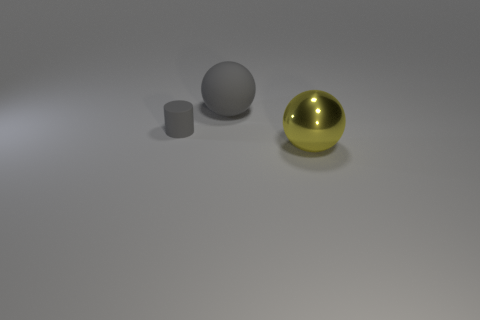How many other things are there of the same color as the shiny sphere?
Keep it short and to the point. 0. Is the material of the ball behind the yellow metal sphere the same as the object that is in front of the cylinder?
Your answer should be compact. No. There is a ball that is on the left side of the big yellow ball; what is its size?
Give a very brief answer. Large. There is a large gray thing that is the same shape as the large yellow thing; what is it made of?
Offer a terse response. Rubber. Is there anything else that is the same size as the gray cylinder?
Provide a succinct answer. No. The big object that is behind the big yellow metallic ball has what shape?
Ensure brevity in your answer.  Sphere. What number of small rubber objects have the same shape as the big gray object?
Your answer should be very brief. 0. Are there an equal number of tiny cylinders that are behind the small gray cylinder and big rubber objects that are to the left of the gray rubber ball?
Your answer should be very brief. Yes. Is there a yellow thing made of the same material as the gray ball?
Your response must be concise. No. Are the small cylinder and the big yellow thing made of the same material?
Provide a short and direct response. No. 